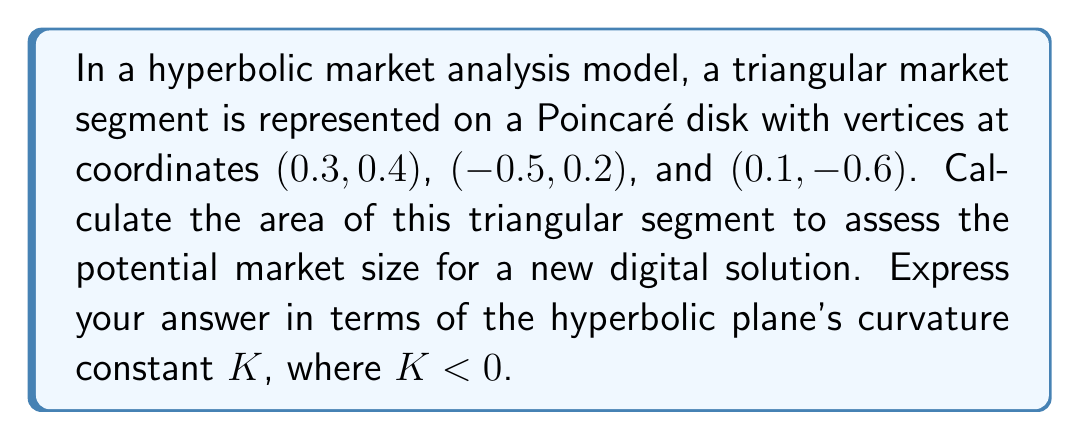Can you solve this math problem? To calculate the area of a triangle on a hyperbolic plane, we'll use the following steps:

1) First, we need to calculate the hyperbolic distances between the vertices. In the Poincaré disk model, the distance $d$ between two points $(x_1, y_1)$ and $(x_2, y_2)$ is given by:

   $$d = \text{arcosh}\left(1 + \frac{2[(x_2-x_1)^2 + (y_2-y_1)^2]}{(1-x_1^2-y_1^2)(1-x_2^2-y_2^2)}\right)$$

2) Let's label our vertices as A(0.3, 0.4), B(-0.5, 0.2), and C(0.1, -0.6). We'll calculate the distances AB, BC, and CA:

   $d_{AB} = \text{arcosh}\left(1 + \frac{2[(0.3+0.5)^2 + (0.4-0.2)^2]}{(1-0.3^2-0.4^2)(1-(-0.5)^2-0.2^2)}\right) \approx 1.3815$

   $d_{BC} = \text{arcosh}\left(1 + \frac{2[(-0.5-0.1)^2 + (0.2+0.6)^2]}{(1-(-0.5)^2-0.2^2)(1-0.1^2-(-0.6)^2)}\right) \approx 1.5591$

   $d_{CA} = \text{arcosh}\left(1 + \frac{2[(0.1-0.3)^2 + (-0.6-0.4)^2]}{(1-0.1^2-(-0.6)^2)(1-0.3^2-0.4^2)}\right) \approx 1.4142$

3) In hyperbolic geometry, the area $A$ of a triangle with sides $a$, $b$, and $c$ is given by:

   $$A = \frac{4}{|K|}\text{arctan}\left(\sqrt{\tan\frac{s}{2}\tan\frac{s-a}{2}\tan\frac{s-b}{2}\tan\frac{s-c}{2}}\right)$$

   where $s = \frac{a+b+c}{2}$ is the semi-perimeter and $K$ is the curvature constant.

4) Calculate the semi-perimeter:

   $s = \frac{1.3815 + 1.5591 + 1.4142}{2} \approx 2.1774$

5) Now we can substitute these values into the area formula:

   $$A = \frac{4}{|K|}\text{arctan}\left(\sqrt{\tan\frac{2.1774}{2}\tan\frac{2.1774-1.3815}{2}\tan\frac{2.1774-1.5591}{2}\tan\frac{2.1774-1.4142}{2}}\right)$$

6) Simplifying:

   $$A = \frac{4}{|K|}\text{arctan}\left(\sqrt{\tan(1.0887)\tan(0.3979)\tan(0.3092)\tan(0.3816)}\right)$$

7) Evaluating:

   $$A = \frac{4}{|K|}\text{arctan}(0.5774) = \frac{4}{|K|} \cdot 0.5236$$

8) Final result:

   $$A = \frac{2.0944}{|K|}$$
Answer: $\frac{2.0944}{|K|}$ square units 